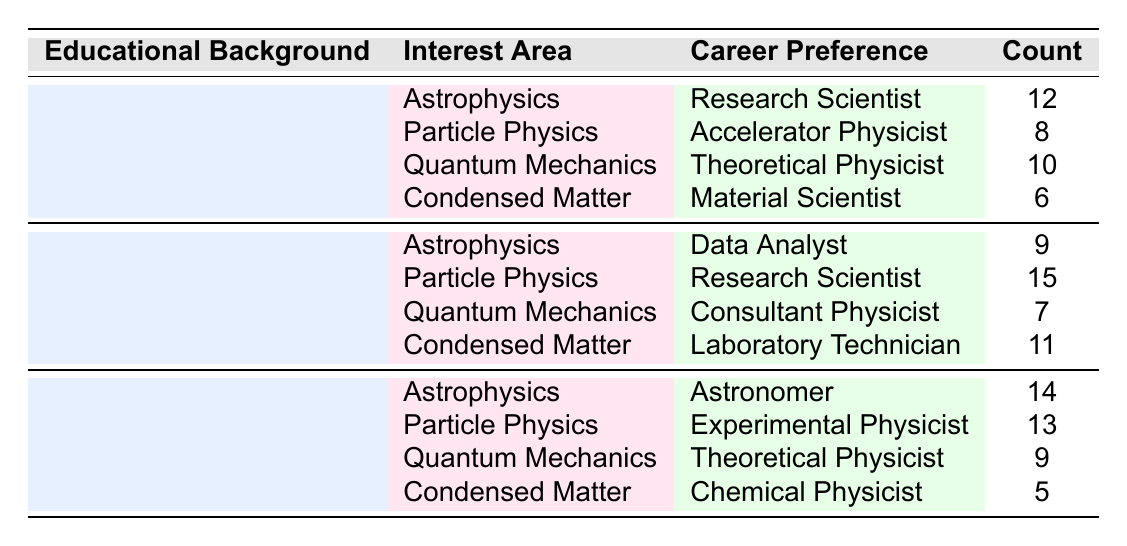What is the most popular career preference for students with a high school educational background interested in particle physics? In the table, the count for "High School" students interested in "Particle Physics" who prefer to become an "Accelerator Physicist" is 8. So, the most popular career preference for this group is "Accelerator Physicist."
Answer: Accelerator Physicist What is the total count of individuals who aspire to be Theoretical Physicists across all educational backgrounds? The total count for Theoretical Physicists is calculated by adding counts for both high school (10) and undergraduate degree (9) categories. So, 10 + 9 = 19.
Answer: 19 Is the count of data analysts from A-Level Physics greater than the count of laboratory technicians from the same educational background? The count for "Data Analyst" in A-Level Physics is 9, while "Laboratory Technician" has a count of 11. Since 9 is less than 11, the statement is false.
Answer: No Which career path has the highest count among those interested in Astrophysics? The highest count in Astrophysics shows that the "Astronomer" career path associated with "Undergraduate Degree" has 14 individuals. This is more than the counts for "Research Scientist" (12) and "Data Analyst" (9) from other educational backgrounds.
Answer: Astronomer How many more individuals prefer to become Research Scientists compared to those who prefer to be Material Scientists from a high school background? The count for Research Scientists in high school is 12 and for Material Scientists is 6. The difference is calculated as 12 - 6 = 6.
Answer: 6 Is there any educational background with a count of 5 for career preferences? Reviewing the table, "Undergraduate Degree" has a count of 5 for "Chemical Physicist." Hence, the answer is yes.
Answer: Yes What is the average count of individuals opting for career paths in Condensed Matter across all educational backgrounds? The counts in Condensed Matter are 6 (High School), 11 (A-Level Physics), and 5 (Undergraduate Degree). Total is 6 + 11 + 5 = 22, and the average is 22 / 3 = approximately 7.33.
Answer: 7.33 Which educational background has the second highest number of total career preferences listed in the table? Adding counts for each educational background: High School (36), A-Level Physics (42), Undergraduate Degree (41). Here, A-Level Physics has the highest, Undergraduate Degree the second highest, and High School the lowest.
Answer: Undergraduate Degree If a student is interested in Quantum Mechanics and has an A-Level Physics background, what is the count for their preferred career? The table states that for students with an A-Level Physics background interested in Quantum Mechanics, the preferred career is "Consultant Physicist," with a count of 7.
Answer: 7 